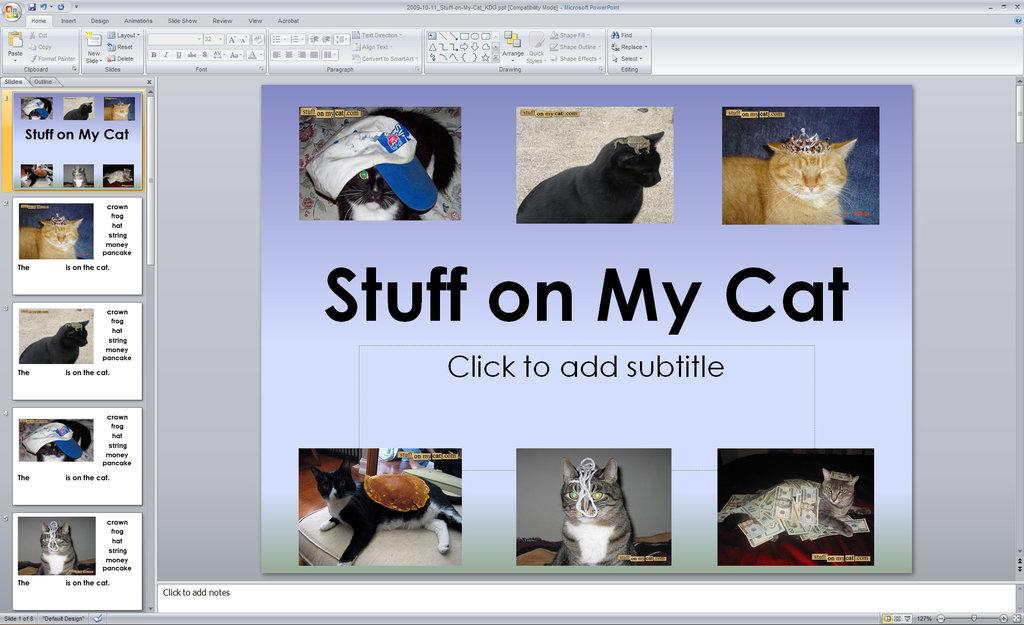What is the main subject of the image? The image contains a snapshot of a screen. What type of images can be seen on the screen? There are pictures of cats on the screen. Is there any text visible on the screen? Yes, there is text visible on the screen. How many guns are visible in the image? There are no guns present in the image; it features pictures of cats and text on a screen. Are there any dogs visible in the image? There are no dogs present in the image; it features pictures of cats and text on a screen. 